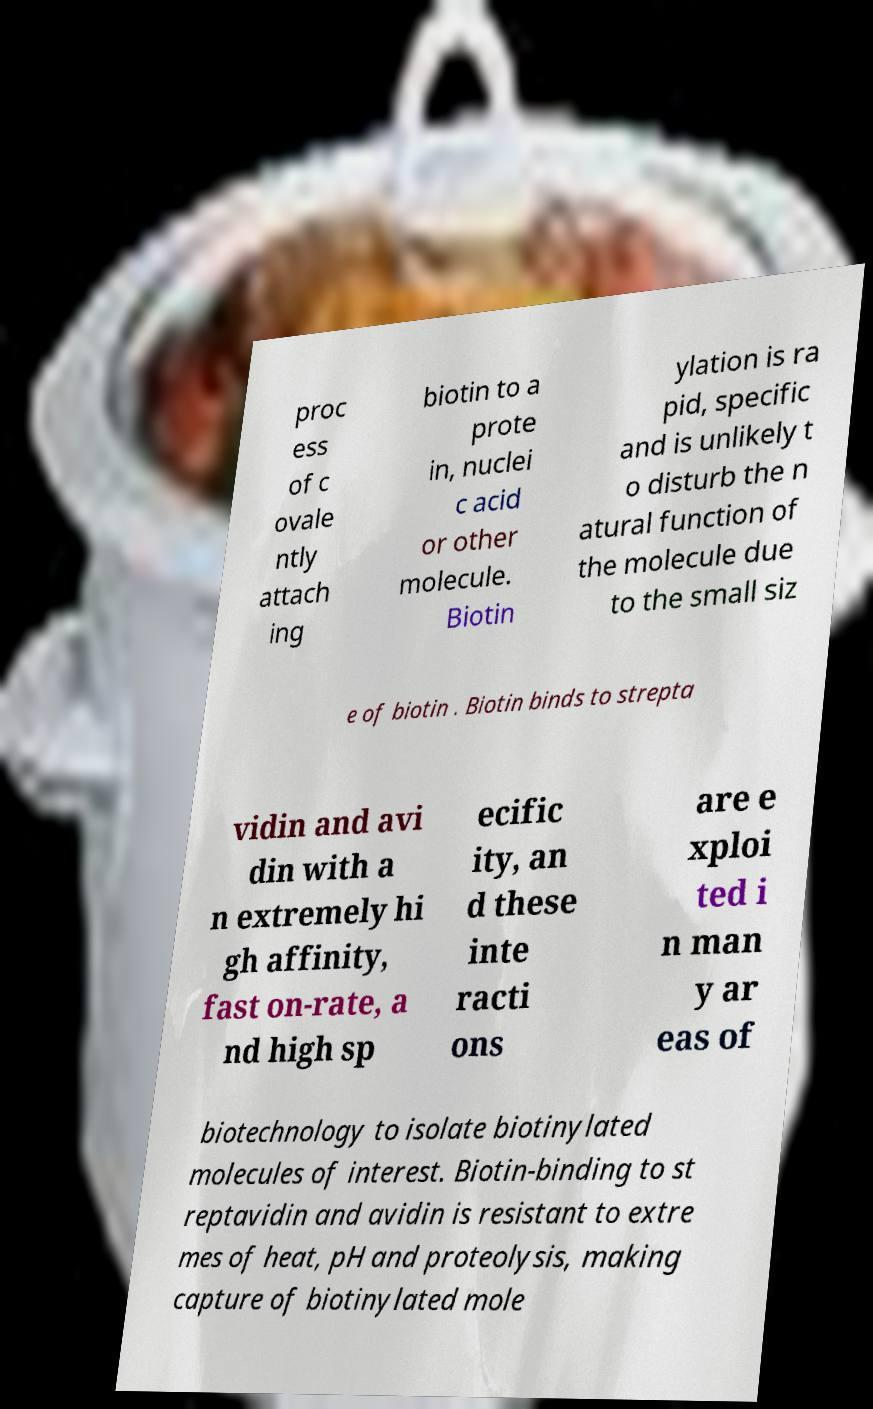There's text embedded in this image that I need extracted. Can you transcribe it verbatim? proc ess of c ovale ntly attach ing biotin to a prote in, nuclei c acid or other molecule. Biotin ylation is ra pid, specific and is unlikely t o disturb the n atural function of the molecule due to the small siz e of biotin . Biotin binds to strepta vidin and avi din with a n extremely hi gh affinity, fast on-rate, a nd high sp ecific ity, an d these inte racti ons are e xploi ted i n man y ar eas of biotechnology to isolate biotinylated molecules of interest. Biotin-binding to st reptavidin and avidin is resistant to extre mes of heat, pH and proteolysis, making capture of biotinylated mole 